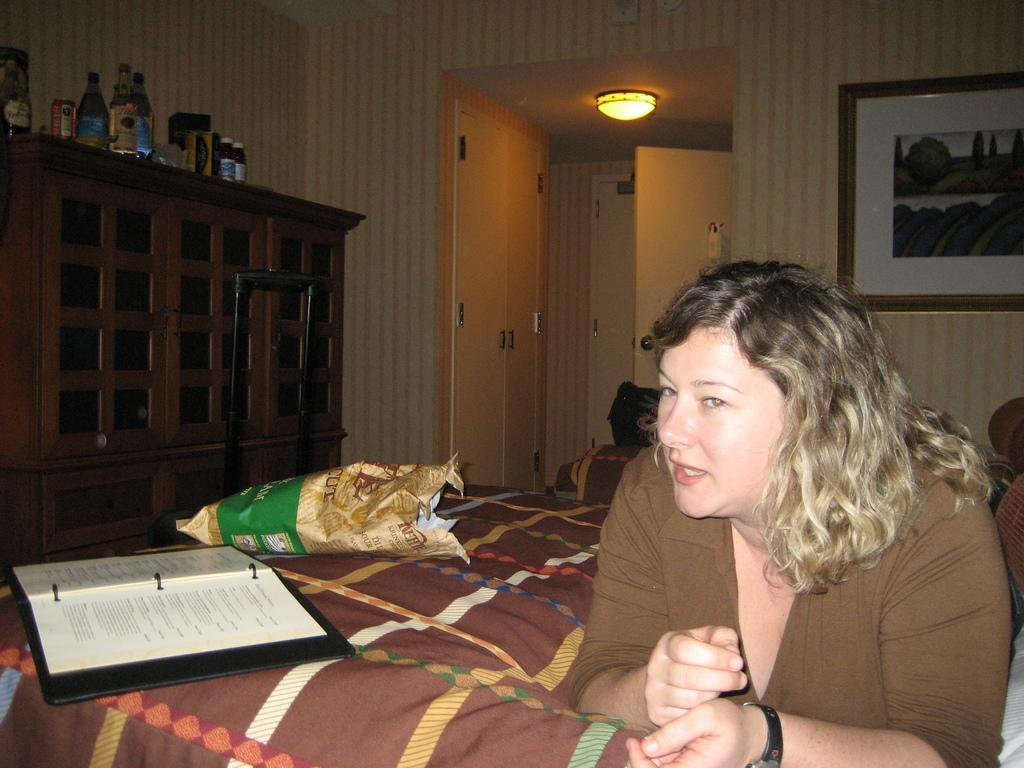Who is present in the image? There is a woman in the image. What is the woman holding in the image? There is a packet in the image. What is placed on a cloth in the image? There is a book on a cloth in the image. Can you describe the background of the image? There is light, bottles, cupboards, walls, doors, a frame, and some objects in the background of the image. What type of grip does the ocean have on the leather in the image? There is no ocean or leather present in the image, so it is not possible to answer that question. 